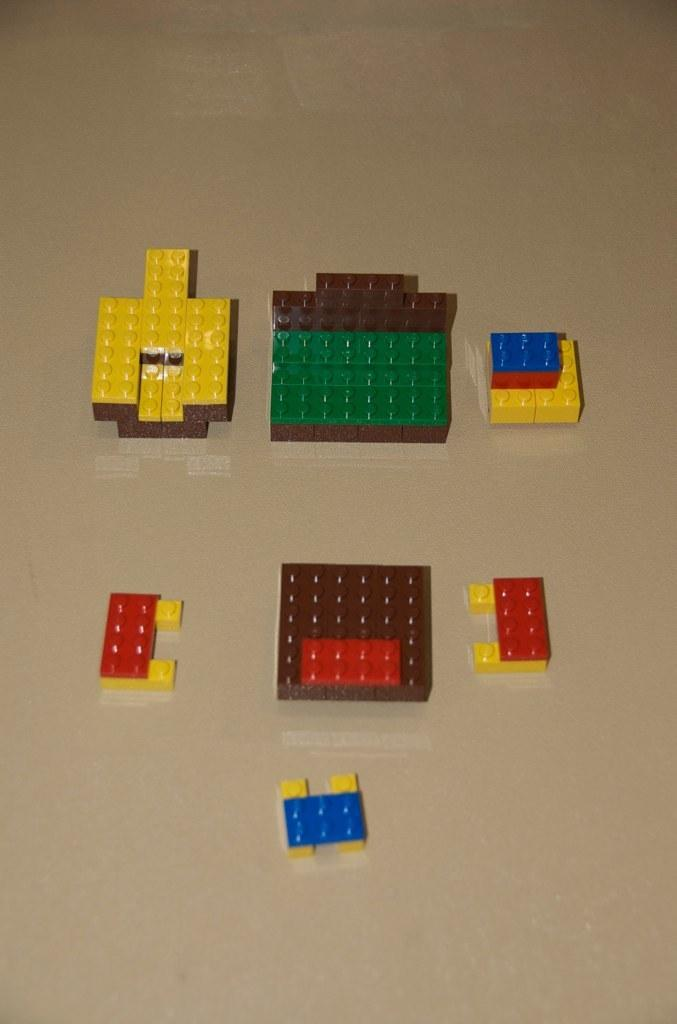What type of objects are on the surface in the image? There are Lego blocks on a surface in the image. What might someone be doing with the Lego blocks in the image? Someone might be building or playing with the Lego blocks in the image. Can you describe the surface on which the Lego blocks are placed? The provided facts do not mention any details about the surface, so we cannot describe it. What type of jam is being spread on the Lego blocks in the image? There is no jam present in the image; it features Lego blocks on a surface. When was the band formed that is playing in the image? There is no band present in the image; it features Lego blocks on a surface. 